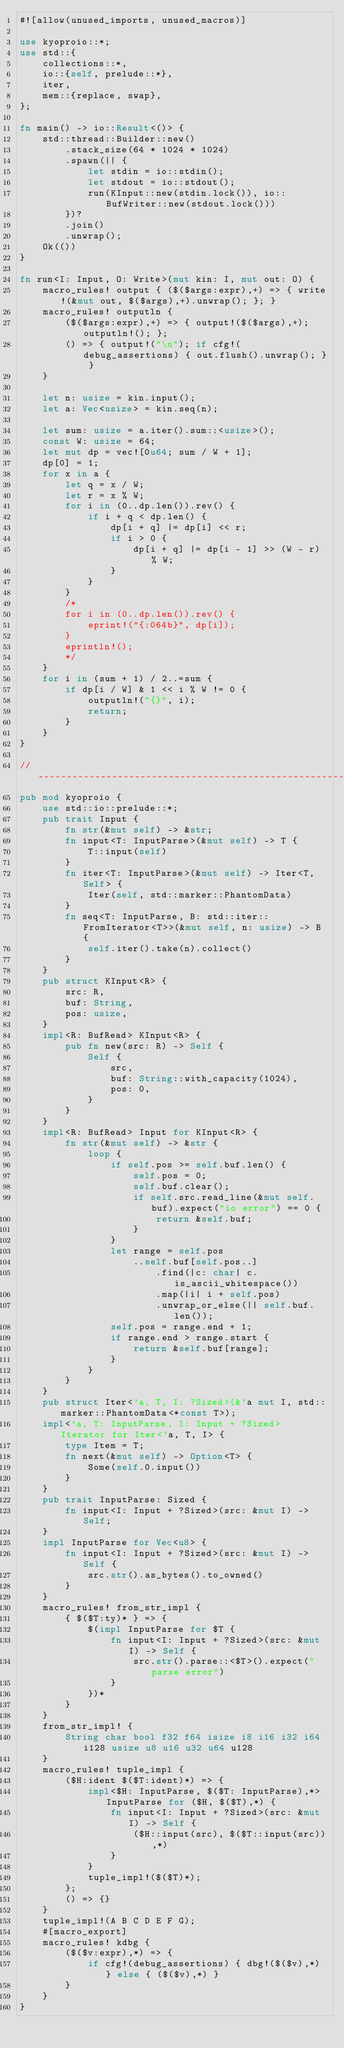Convert code to text. <code><loc_0><loc_0><loc_500><loc_500><_Rust_>#![allow(unused_imports, unused_macros)]

use kyoproio::*;
use std::{
    collections::*,
    io::{self, prelude::*},
    iter,
    mem::{replace, swap},
};

fn main() -> io::Result<()> {
    std::thread::Builder::new()
        .stack_size(64 * 1024 * 1024)
        .spawn(|| {
            let stdin = io::stdin();
            let stdout = io::stdout();
            run(KInput::new(stdin.lock()), io::BufWriter::new(stdout.lock()))
        })?
        .join()
        .unwrap();
    Ok(())
}

fn run<I: Input, O: Write>(mut kin: I, mut out: O) {
    macro_rules! output { ($($args:expr),+) => { write!(&mut out, $($args),+).unwrap(); }; }
    macro_rules! outputln {
        ($($args:expr),+) => { output!($($args),+); outputln!(); };
        () => { output!("\n"); if cfg!(debug_assertions) { out.flush().unwrap(); } }
    }

    let n: usize = kin.input();
    let a: Vec<usize> = kin.seq(n);

    let sum: usize = a.iter().sum::<usize>();
    const W: usize = 64;
    let mut dp = vec![0u64; sum / W + 1];
    dp[0] = 1;
    for x in a {
        let q = x / W;
        let r = x % W;
        for i in (0..dp.len()).rev() {
            if i + q < dp.len() {
                dp[i + q] |= dp[i] << r;
                if i > 0 {
                    dp[i + q] |= dp[i - 1] >> (W - r) % W;
                }
            }
        }
        /*
        for i in (0..dp.len()).rev() {
            eprint!("{:064b}", dp[i]);
        }
        eprintln!();
        */
    }
    for i in (sum + 1) / 2..=sum {
        if dp[i / W] & 1 << i % W != 0 {
            outputln!("{}", i);
            return;
        }
    }
}

// -----------------------------------------------------------------------------
pub mod kyoproio {
    use std::io::prelude::*;
    pub trait Input {
        fn str(&mut self) -> &str;
        fn input<T: InputParse>(&mut self) -> T {
            T::input(self)
        }
        fn iter<T: InputParse>(&mut self) -> Iter<T, Self> {
            Iter(self, std::marker::PhantomData)
        }
        fn seq<T: InputParse, B: std::iter::FromIterator<T>>(&mut self, n: usize) -> B {
            self.iter().take(n).collect()
        }
    }
    pub struct KInput<R> {
        src: R,
        buf: String,
        pos: usize,
    }
    impl<R: BufRead> KInput<R> {
        pub fn new(src: R) -> Self {
            Self {
                src,
                buf: String::with_capacity(1024),
                pos: 0,
            }
        }
    }
    impl<R: BufRead> Input for KInput<R> {
        fn str(&mut self) -> &str {
            loop {
                if self.pos >= self.buf.len() {
                    self.pos = 0;
                    self.buf.clear();
                    if self.src.read_line(&mut self.buf).expect("io error") == 0 {
                        return &self.buf;
                    }
                }
                let range = self.pos
                    ..self.buf[self.pos..]
                        .find(|c: char| c.is_ascii_whitespace())
                        .map(|i| i + self.pos)
                        .unwrap_or_else(|| self.buf.len());
                self.pos = range.end + 1;
                if range.end > range.start {
                    return &self.buf[range];
                }
            }
        }
    }
    pub struct Iter<'a, T, I: ?Sized>(&'a mut I, std::marker::PhantomData<*const T>);
    impl<'a, T: InputParse, I: Input + ?Sized> Iterator for Iter<'a, T, I> {
        type Item = T;
        fn next(&mut self) -> Option<T> {
            Some(self.0.input())
        }
    }
    pub trait InputParse: Sized {
        fn input<I: Input + ?Sized>(src: &mut I) -> Self;
    }
    impl InputParse for Vec<u8> {
        fn input<I: Input + ?Sized>(src: &mut I) -> Self {
            src.str().as_bytes().to_owned()
        }
    }
    macro_rules! from_str_impl {
        { $($T:ty)* } => {
            $(impl InputParse for $T {
                fn input<I: Input + ?Sized>(src: &mut I) -> Self {
                    src.str().parse::<$T>().expect("parse error")
                }
            })*
        }
    }
    from_str_impl! {
        String char bool f32 f64 isize i8 i16 i32 i64 i128 usize u8 u16 u32 u64 u128
    }
    macro_rules! tuple_impl {
        ($H:ident $($T:ident)*) => {
            impl<$H: InputParse, $($T: InputParse),*> InputParse for ($H, $($T),*) {
                fn input<I: Input + ?Sized>(src: &mut I) -> Self {
                    ($H::input(src), $($T::input(src)),*)
                }
            }
            tuple_impl!($($T)*);
        };
        () => {}
    }
    tuple_impl!(A B C D E F G);
    #[macro_export]
    macro_rules! kdbg {
        ($($v:expr),*) => {
            if cfg!(debug_assertions) { dbg!($($v),*) } else { ($($v),*) }
        }
    }
}
</code> 